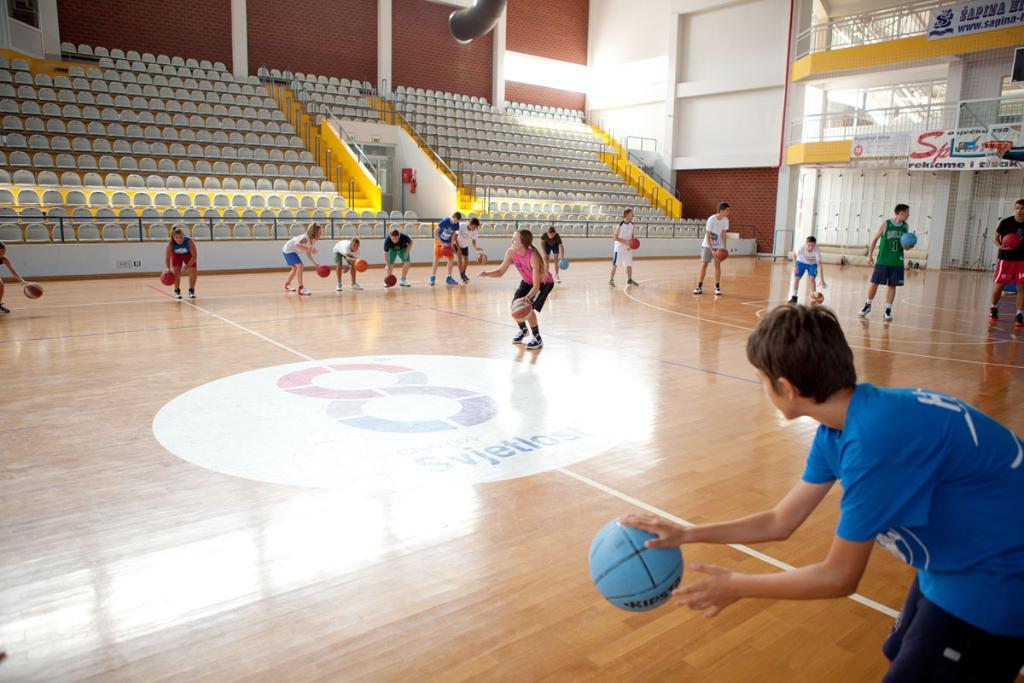<image>
Render a clear and concise summary of the photo. A player in a green jersey with the number 1 on it plays with his classmates in gym. 